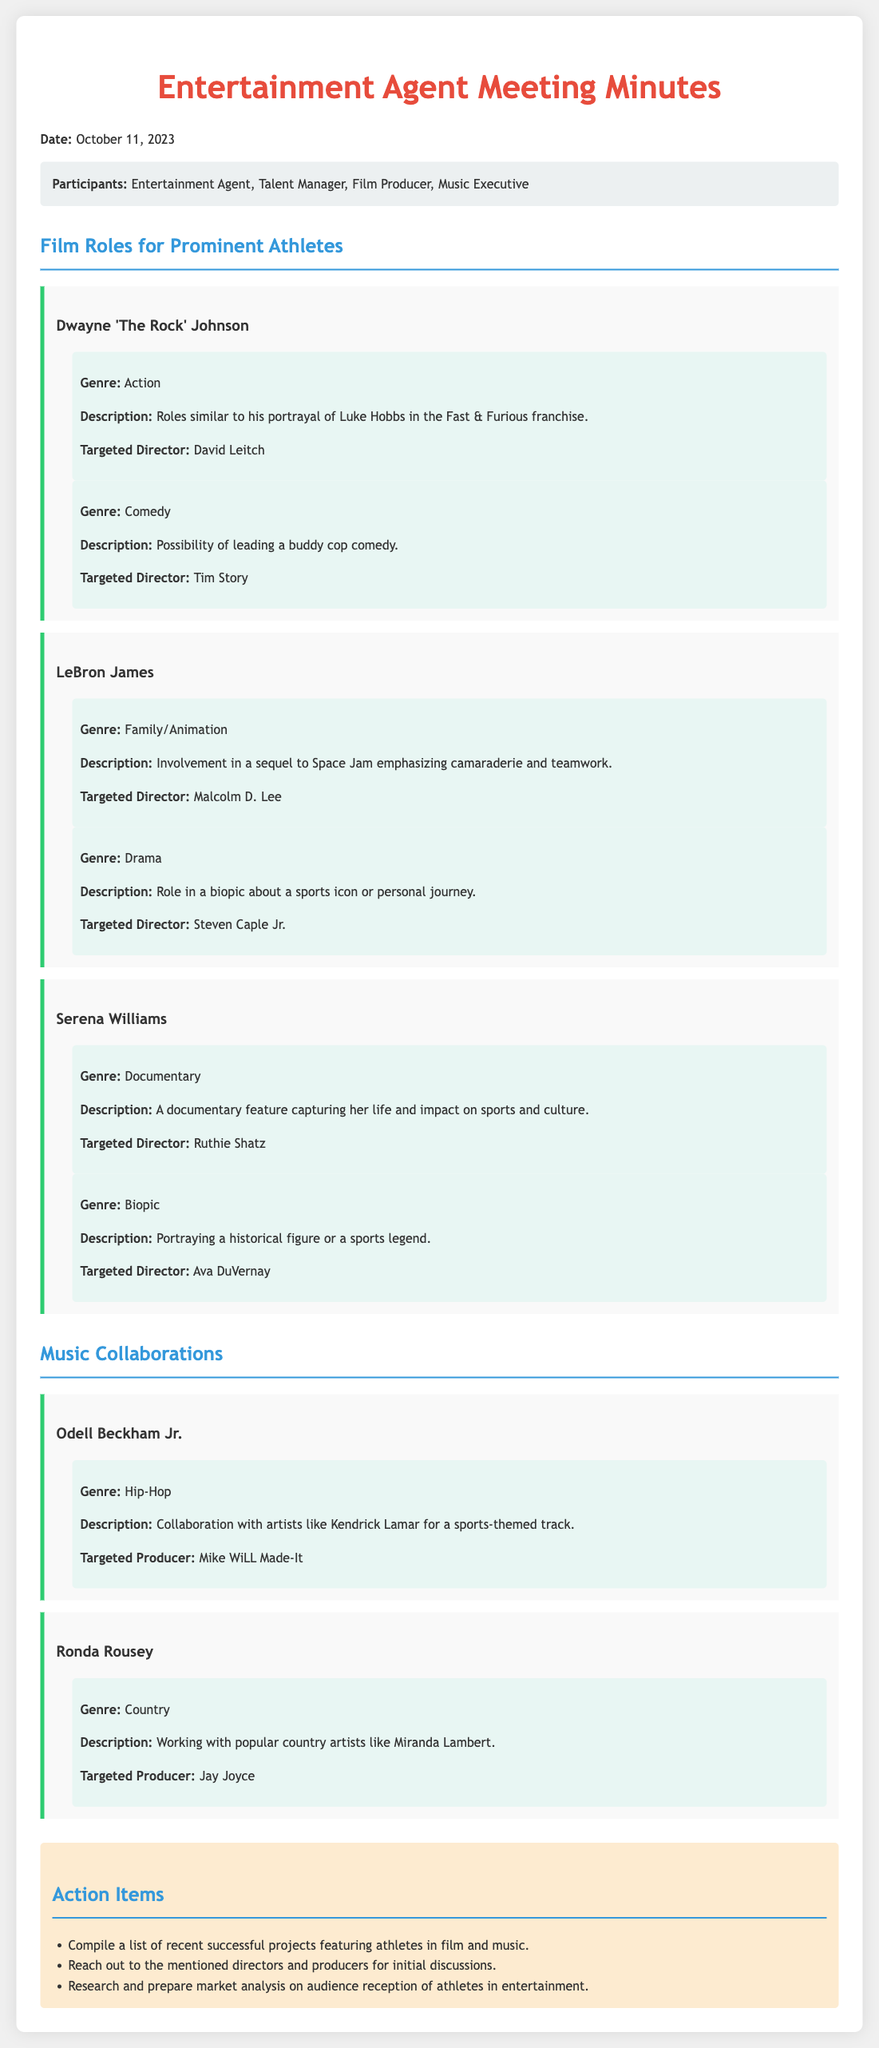What is the date of the meeting? The date of the meeting is explicitly stated in the document header.
Answer: October 11, 2023 Who is the targeted director for Dwayne Johnson's action role? This information is located within the section detailing roles for athletes, specifying the targeted director for Dwayne Johnson's action genre role.
Answer: David Leitch What genre is LeBron James's drama role? The document lists the genres associated with LeBron James's potential roles and specifies the drama genre.
Answer: Drama How many action items are listed in the document? The action items section at the end of the document provides a list which can be counted for the total.
Answer: 3 Which athlete is suggested for a collaboration in the hip-hop genre? The section on music collaborations details the specific athletes and their respective genres.
Answer: Odell Beckham Jr What role is proposed for Serena Williams in the documentary genre? The document describes the type of roles for Serena Williams, specifically within the documentary section.
Answer: A documentary feature capturing her life and impact on sports and culture What is the targeted producer for Ronda Rousey’s country music collaboration? The collaboration section for Ronda Rousey includes specific details of the targeted producer for her music project.
Answer: Jay Joyce What type of film role is suggested for LeBron James in the family genre? This is found in the roles section for LeBron James indicating the film genre related to family/animation.
Answer: Family/Animation What is one action item regarding market analysis in the document? The action items section mentions tasks including preparations for market analysis related to athletes in entertainment.
Answer: Research and prepare market analysis on audience reception of athletes in entertainment 